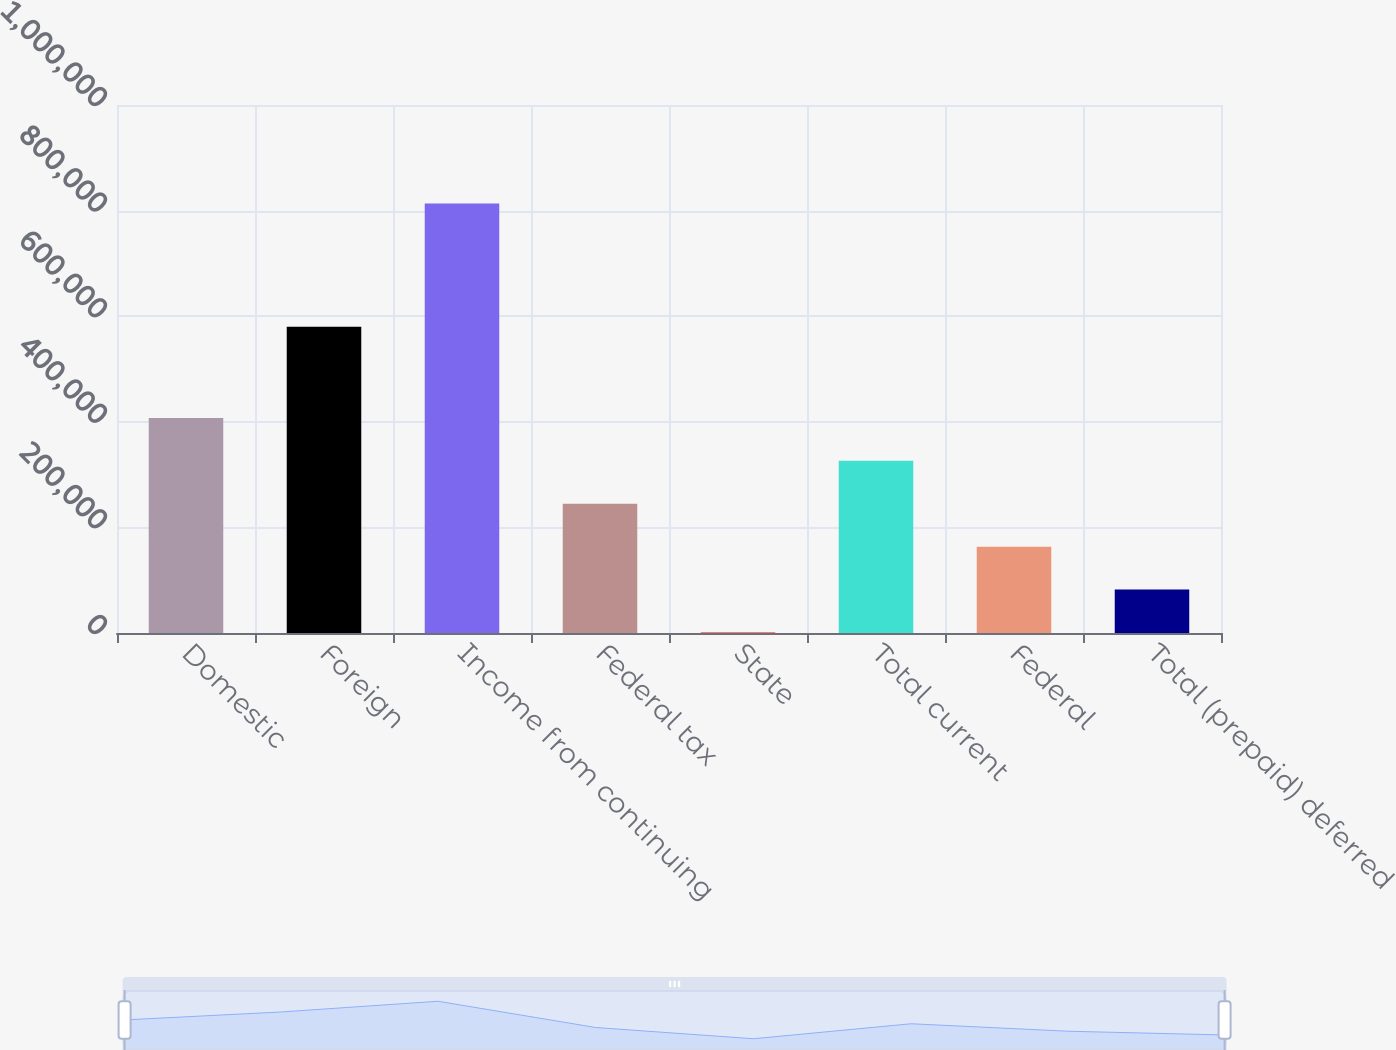<chart> <loc_0><loc_0><loc_500><loc_500><bar_chart><fcel>Domestic<fcel>Foreign<fcel>Income from continuing<fcel>Federal tax<fcel>State<fcel>Total current<fcel>Federal<fcel>Total (prepaid) deferred<nl><fcel>407252<fcel>580055<fcel>813533<fcel>244739<fcel>970<fcel>325995<fcel>163483<fcel>82226.3<nl></chart> 